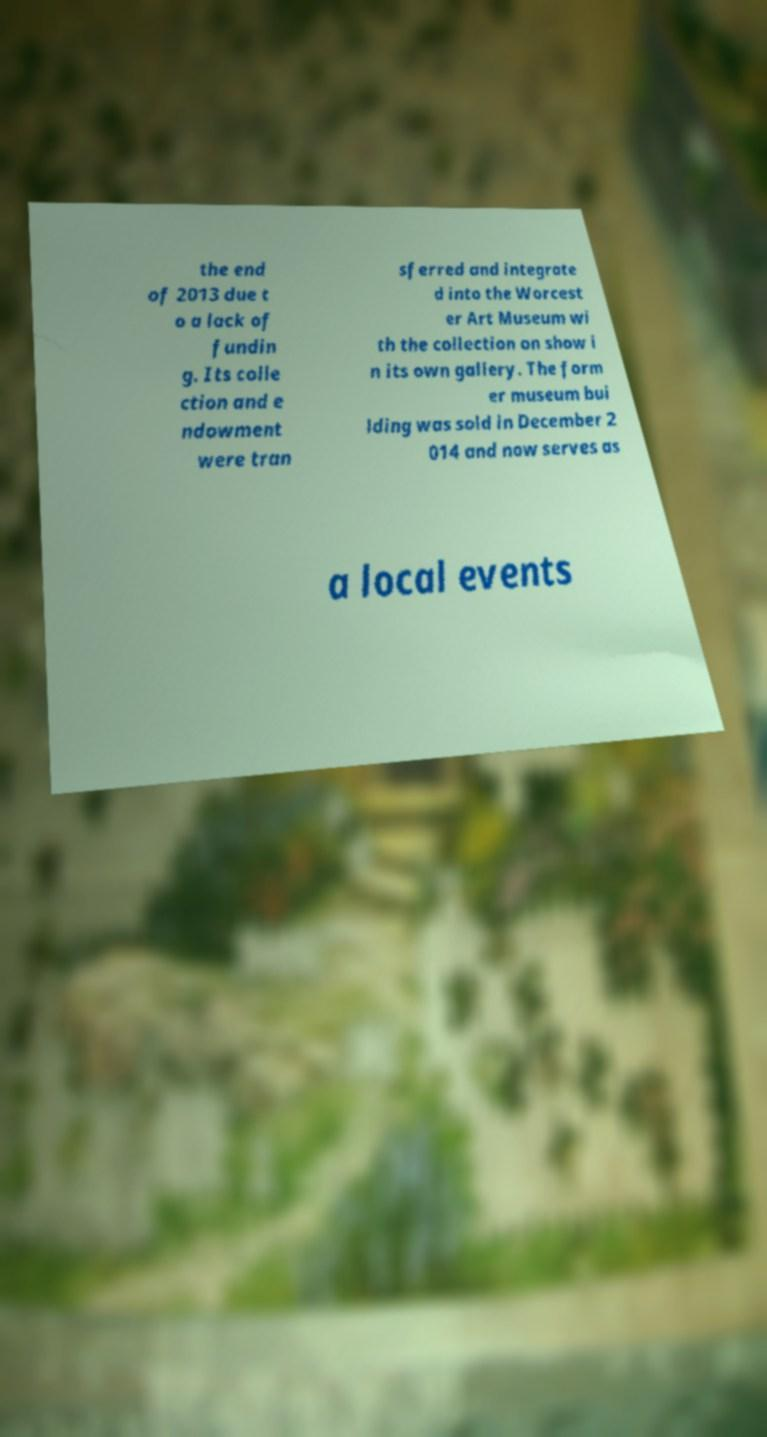Please read and relay the text visible in this image. What does it say? the end of 2013 due t o a lack of fundin g. Its colle ction and e ndowment were tran sferred and integrate d into the Worcest er Art Museum wi th the collection on show i n its own gallery. The form er museum bui lding was sold in December 2 014 and now serves as a local events 